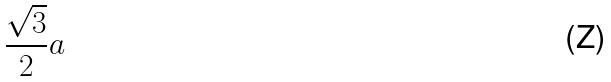<formula> <loc_0><loc_0><loc_500><loc_500>\frac { \sqrt { 3 } } { 2 } a</formula> 